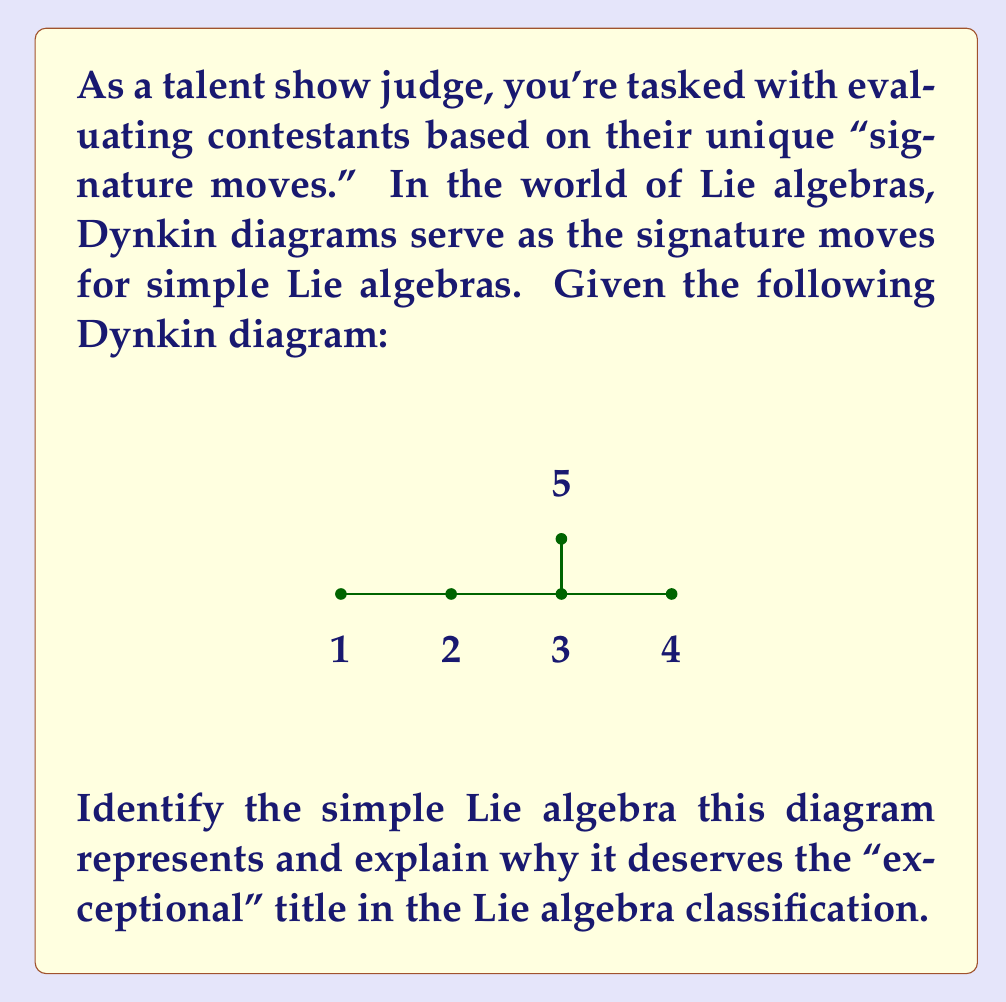Can you solve this math problem? To classify this simple Lie algebra using its Dynkin diagram, we'll follow these steps:

1) Observe the diagram structure:
   - It has 5 nodes, indicating a rank-5 algebra.
   - The nodes are connected in a T-shape.

2) Recall the classification of simple Lie algebras:
   - Classical series: $A_n$, $B_n$, $C_n$, $D_n$
   - Exceptional algebras: $G_2$, $F_4$, $E_6$, $E_7$, $E_8$

3) The T-shape is characteristic of the exceptional $E$ series.

4) Among the $E$ series, only $E_6$ has rank 5 (5 nodes).

5) The $E_6$ Dynkin diagram matches our given diagram exactly.

6) $E_6$ is considered "exceptional" because:
   a) It doesn't belong to any of the infinite classical series.
   b) It's one of only five exceptional simple Lie algebras.
   c) It has unique properties not shared by classical algebras, such as:
      - A higher degree of symmetry
      - Connections to exceptional objects in other areas of mathematics
      - Applications in theoretical physics, particularly string theory

7) The "exceptional" title in Lie algebra classification is analogous to a contestant with a truly unique and remarkable talent that doesn't fit into standard categories.
Answer: The Dynkin diagram represents the exceptional Lie algebra $E_6$. It's considered "exceptional" because it's one of only five simple Lie algebras that don't belong to the infinite classical series, possessing unique properties and symmetries not found in classical algebras. 